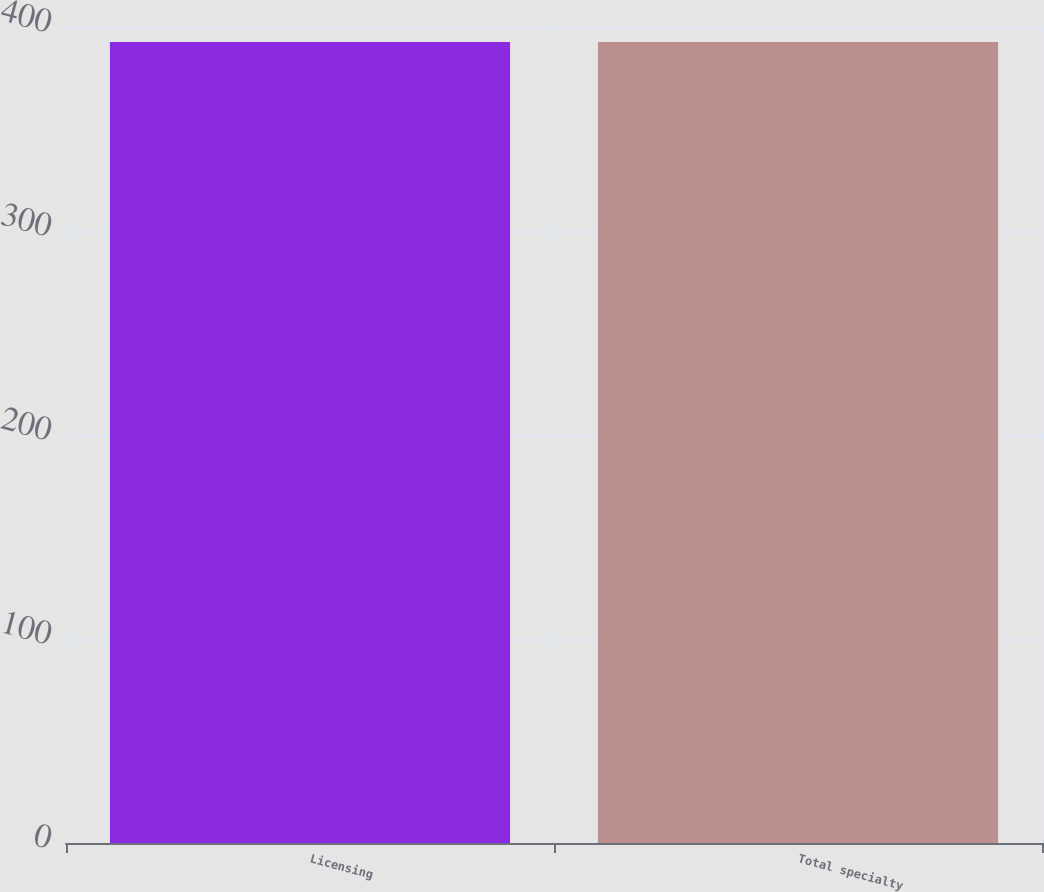<chart> <loc_0><loc_0><loc_500><loc_500><bar_chart><fcel>Licensing<fcel>Total specialty<nl><fcel>392.6<fcel>392.7<nl></chart> 